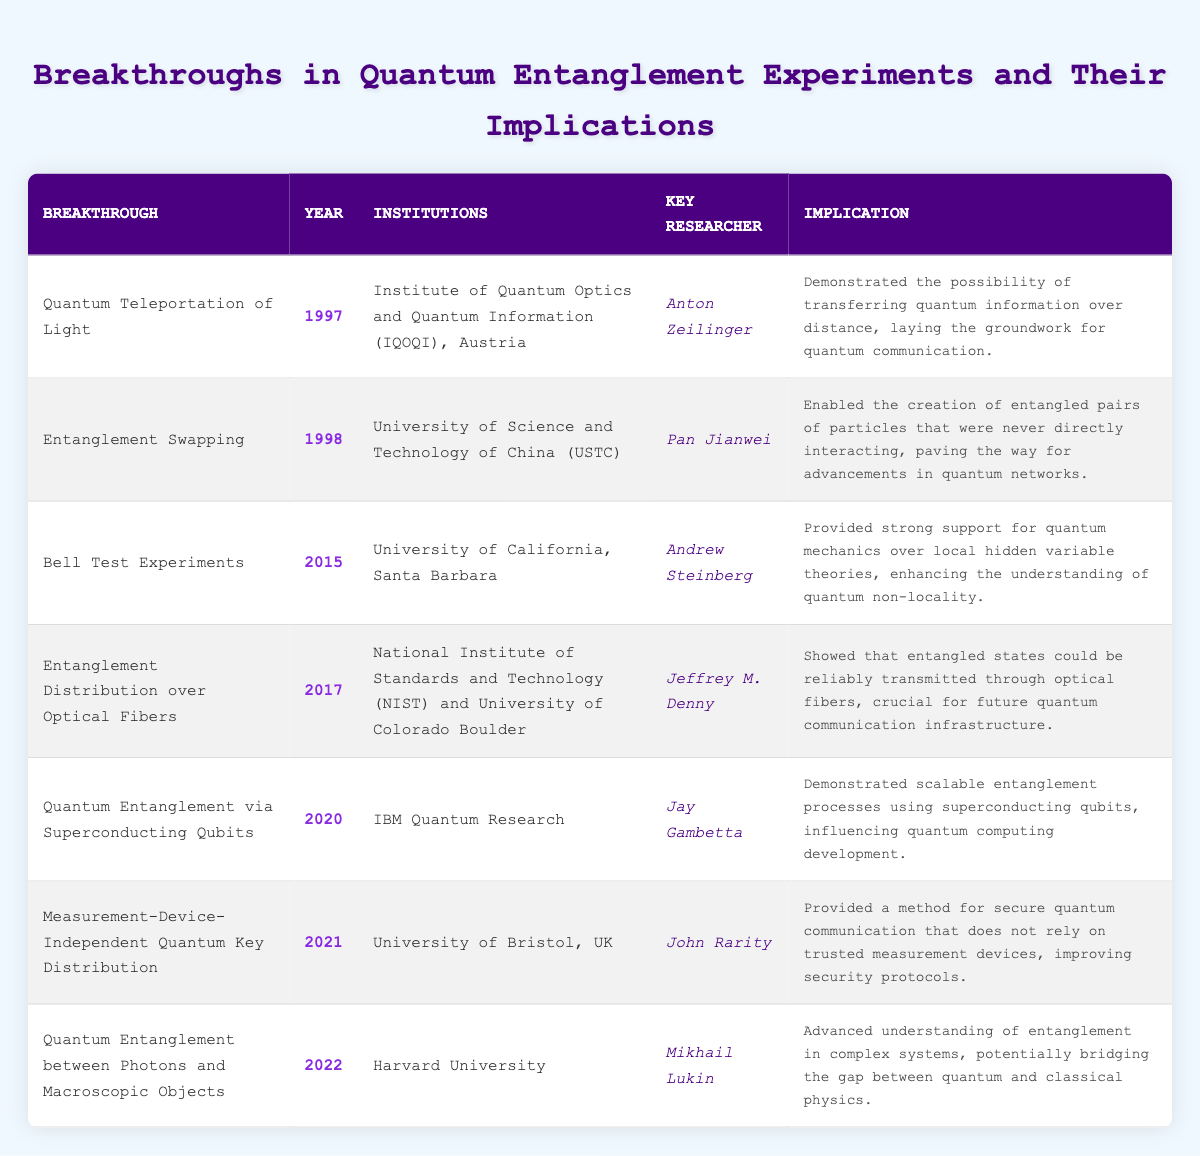What breakthrough occurred in 2021? The table lists "Measurement-Device-Independent Quantum Key Distribution" as the breakthrough for the year 2021.
Answer: Measurement-Device-Independent Quantum Key Distribution Which institution was involved in the 2015 Bell Test Experiments? According to the table, the University of California, Santa Barbara was the institution involved in the 2015 Bell Test Experiments.
Answer: University of California, Santa Barbara How many breakthroughs are listed after the year 2015? From the table, there are three breakthroughs listed after 2015: one in 2017, one in 2020, and another in 2021. This sums up to three breakthroughs.
Answer: 3 Who is the key researcher for the breakthrough that enabled entangled pairs of particles in 1998? The table indicates that Pan Jianwei is the key researcher for the "Entanglement Swapping" breakthrough in 1998.
Answer: Pan Jianwei What is the implication of the breakthrough "Quantum Teleportation of Light"? The implication provided in the table states that it demonstrated the possibility of transferring quantum information over distance, laying the groundwork for quantum communication.
Answer: Transferring quantum information for communication Which researcher contributed to two breakthroughs listed in the table? Upon checking the table, it appears that no single researcher is listed for two breakthroughs; therefore, the answer is no.
Answer: No What is the average year of breakthroughs listed in the table? The years associated with the breakthroughs are 1997, 1998, 2015, 2017, 2020, 2021, and 2022. To find the average, sum these years: (1997 + 1998 + 2015 + 2017 + 2020 + 2021 + 2022) = 14190. Then divide by 7 (the number of breakthroughs), which gives approximately 2027.14. Hence, rounding to the nearest year gives 2022.
Answer: 2022 Is there a breakthrough related to quantum communication that occurred in 2020? Looking at the table, the breakthrough in 2020 is "Quantum Entanglement via Superconducting Qubits." This breakthrough specifically influences quantum computing but does not mention quantum communication, thus the answer is no.
Answer: No Which breakthrough has the longest implication description in the table? By visually inspecting the implication descriptions, "Quantum Entanglement between Photons and Macroscopic Objects" is noted to have the longest description.
Answer: Quantum Entanglement between Photons and Macroscopic Objects How many years apart are the breakthroughs from 1998 and 2017? The year for the 1998 breakthrough is 1998, and the year for the 2017 breakthrough is 2017. Calculating the difference, 2017 - 1998 = 19 years apart.
Answer: 19 years 